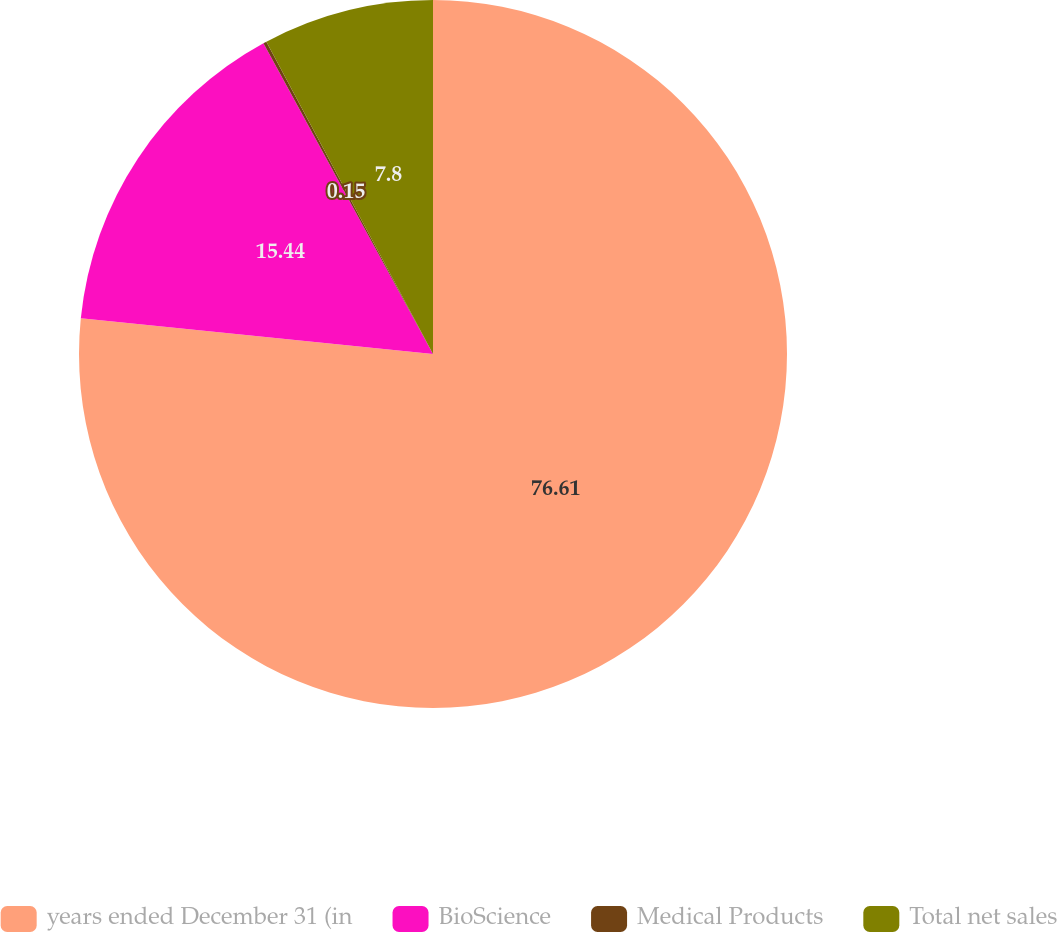<chart> <loc_0><loc_0><loc_500><loc_500><pie_chart><fcel>years ended December 31 (in<fcel>BioScience<fcel>Medical Products<fcel>Total net sales<nl><fcel>76.61%<fcel>15.44%<fcel>0.15%<fcel>7.8%<nl></chart> 